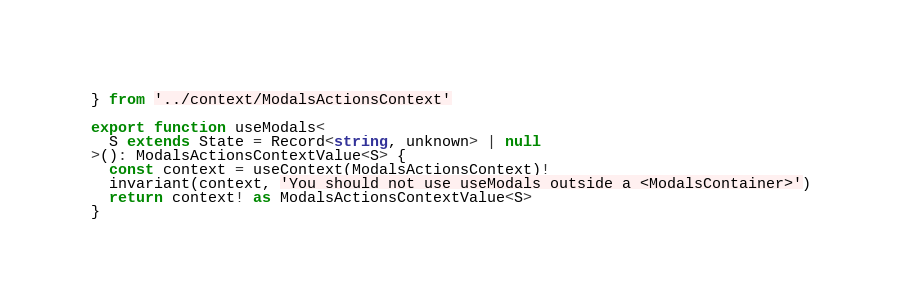<code> <loc_0><loc_0><loc_500><loc_500><_TypeScript_>} from '../context/ModalsActionsContext'

export function useModals<
  S extends State = Record<string, unknown> | null
>(): ModalsActionsContextValue<S> {
  const context = useContext(ModalsActionsContext)!
  invariant(context, 'You should not use useModals outside a <ModalsContainer>')
  return context! as ModalsActionsContextValue<S>
}
</code> 